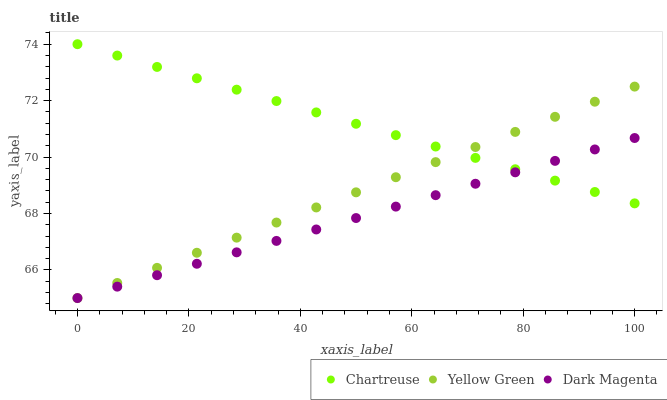Does Dark Magenta have the minimum area under the curve?
Answer yes or no. Yes. Does Chartreuse have the maximum area under the curve?
Answer yes or no. Yes. Does Yellow Green have the minimum area under the curve?
Answer yes or no. No. Does Yellow Green have the maximum area under the curve?
Answer yes or no. No. Is Dark Magenta the smoothest?
Answer yes or no. Yes. Is Chartreuse the roughest?
Answer yes or no. Yes. Is Yellow Green the smoothest?
Answer yes or no. No. Is Yellow Green the roughest?
Answer yes or no. No. Does Yellow Green have the lowest value?
Answer yes or no. Yes. Does Chartreuse have the highest value?
Answer yes or no. Yes. Does Yellow Green have the highest value?
Answer yes or no. No. Does Dark Magenta intersect Yellow Green?
Answer yes or no. Yes. Is Dark Magenta less than Yellow Green?
Answer yes or no. No. Is Dark Magenta greater than Yellow Green?
Answer yes or no. No. 